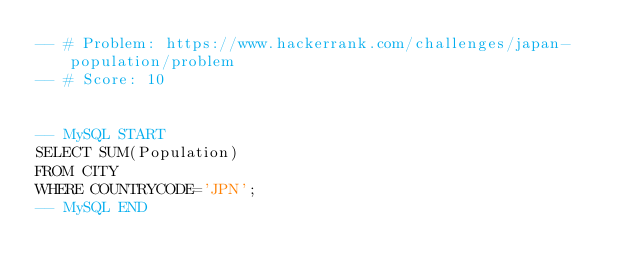Convert code to text. <code><loc_0><loc_0><loc_500><loc_500><_SQL_>-- # Problem: https://www.hackerrank.com/challenges/japan-population/problem
-- # Score: 10


-- MySQL START
SELECT SUM(Population)
FROM CITY
WHERE COUNTRYCODE='JPN';
-- MySQL END
</code> 